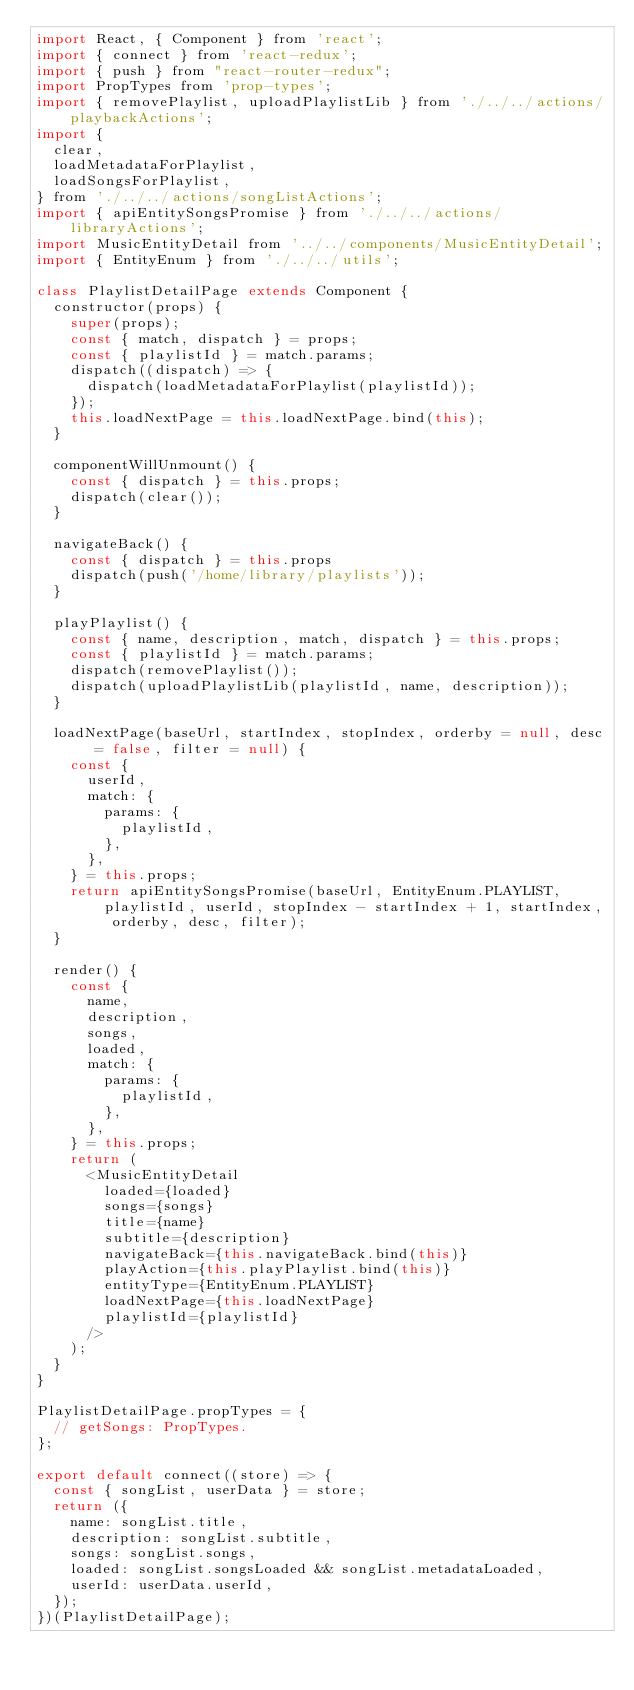<code> <loc_0><loc_0><loc_500><loc_500><_JavaScript_>import React, { Component } from 'react';
import { connect } from 'react-redux';
import { push } from "react-router-redux";
import PropTypes from 'prop-types';
import { removePlaylist, uploadPlaylistLib } from './../../actions/playbackActions';
import {
  clear,
  loadMetadataForPlaylist,
  loadSongsForPlaylist,
} from './../../actions/songListActions';
import { apiEntitySongsPromise } from './../../actions/libraryActions';
import MusicEntityDetail from '../../components/MusicEntityDetail';
import { EntityEnum } from './../../utils';

class PlaylistDetailPage extends Component {
  constructor(props) {
    super(props);
    const { match, dispatch } = props;
    const { playlistId } = match.params;
    dispatch((dispatch) => {
      dispatch(loadMetadataForPlaylist(playlistId));
    });
    this.loadNextPage = this.loadNextPage.bind(this);
  }

  componentWillUnmount() {
    const { dispatch } = this.props;
    dispatch(clear());
  }

  navigateBack() {
    const { dispatch } = this.props
    dispatch(push('/home/library/playlists'));
  }

  playPlaylist() {
    const { name, description, match, dispatch } = this.props;
    const { playlistId } = match.params;
    dispatch(removePlaylist());
    dispatch(uploadPlaylistLib(playlistId, name, description));
  }

  loadNextPage(baseUrl, startIndex, stopIndex, orderby = null, desc = false, filter = null) {
    const {
      userId,
      match: {
        params: {
          playlistId,
        },
      },
    } = this.props;
    return apiEntitySongsPromise(baseUrl, EntityEnum.PLAYLIST, playlistId, userId, stopIndex - startIndex + 1, startIndex, orderby, desc, filter);
  }

  render() {
    const {
      name,
      description,
      songs,
      loaded,
      match: {
        params: {
          playlistId,
        },
      },
    } = this.props;
    return (
      <MusicEntityDetail
        loaded={loaded}
        songs={songs}
        title={name}
        subtitle={description}
        navigateBack={this.navigateBack.bind(this)}
        playAction={this.playPlaylist.bind(this)}
        entityType={EntityEnum.PLAYLIST}
        loadNextPage={this.loadNextPage}
        playlistId={playlistId}
      />
    );
  }
}

PlaylistDetailPage.propTypes = {
  // getSongs: PropTypes.
};

export default connect((store) => {
  const { songList, userData } = store;
  return ({
    name: songList.title,
    description: songList.subtitle,
    songs: songList.songs,
    loaded: songList.songsLoaded && songList.metadataLoaded,
    userId: userData.userId,
  });
})(PlaylistDetailPage);
</code> 